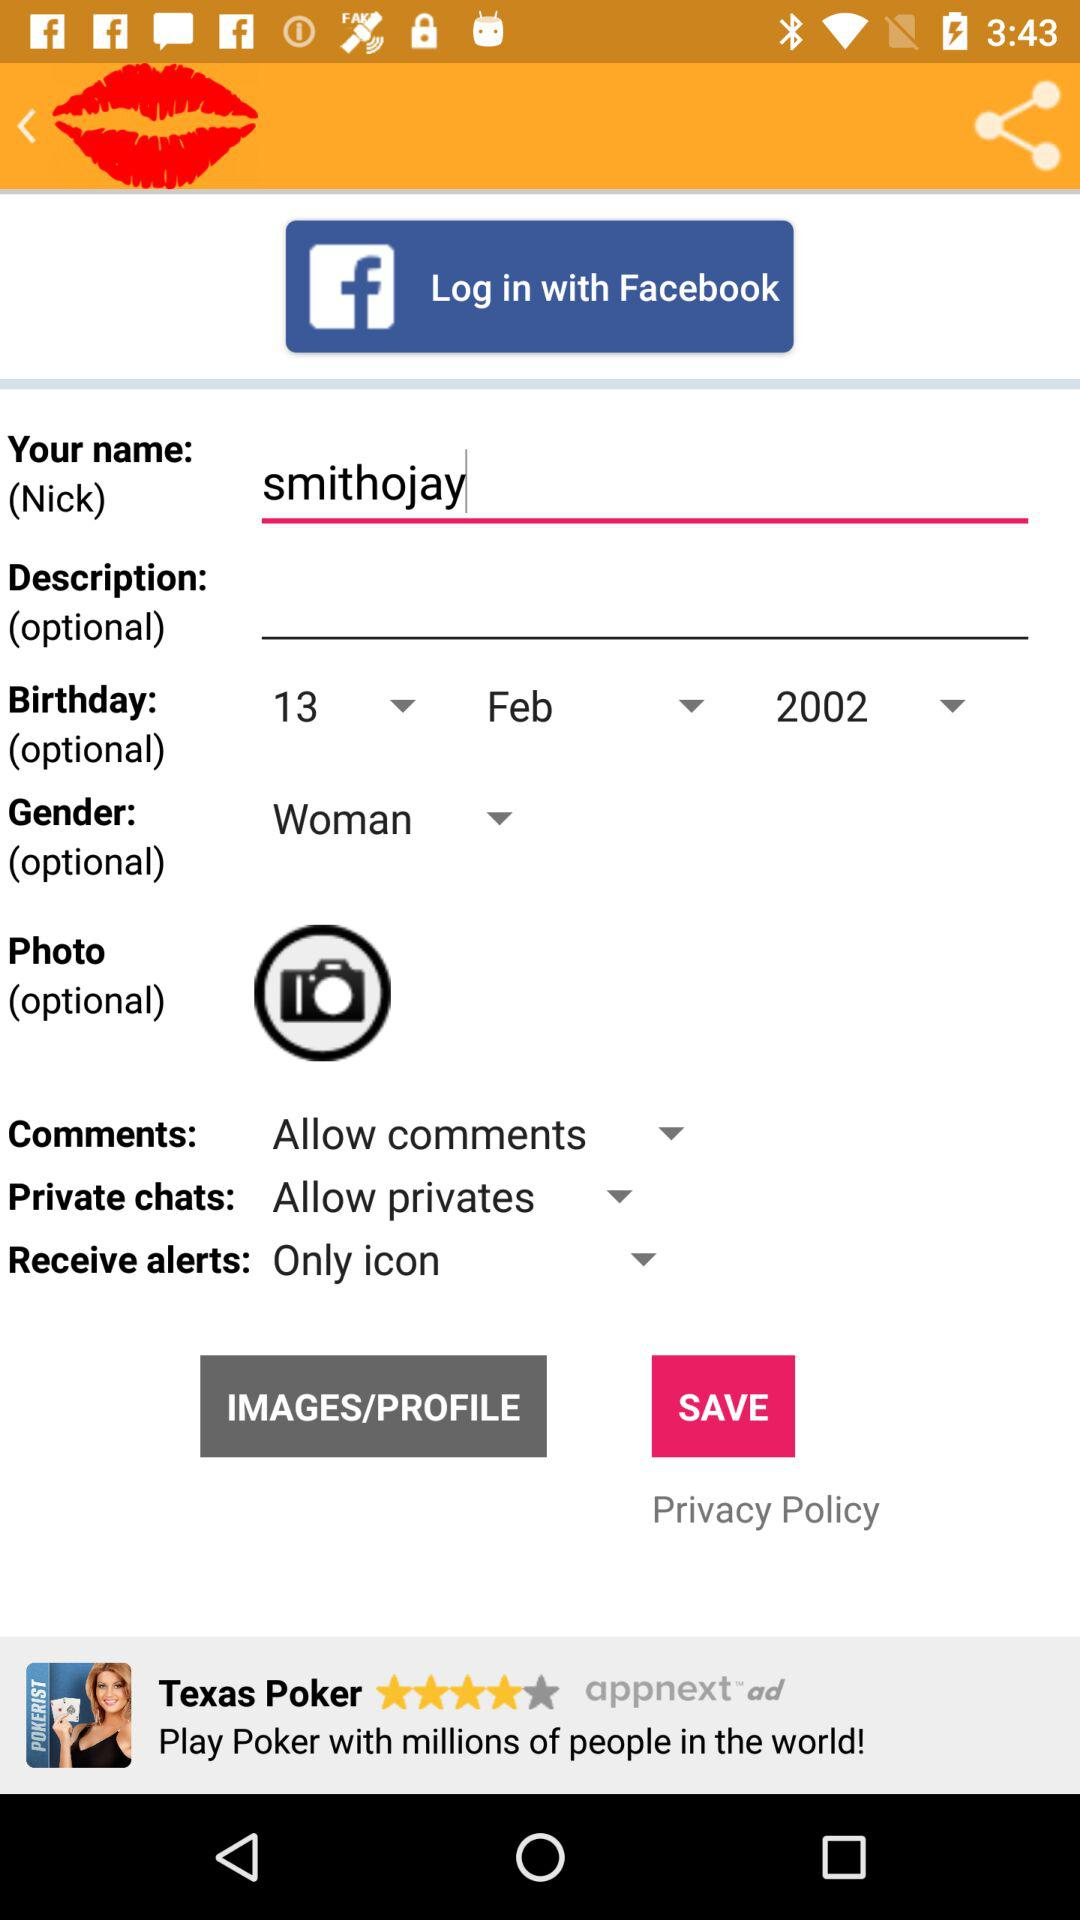What is the setting for the private chats? The setting is "Allow privates". 